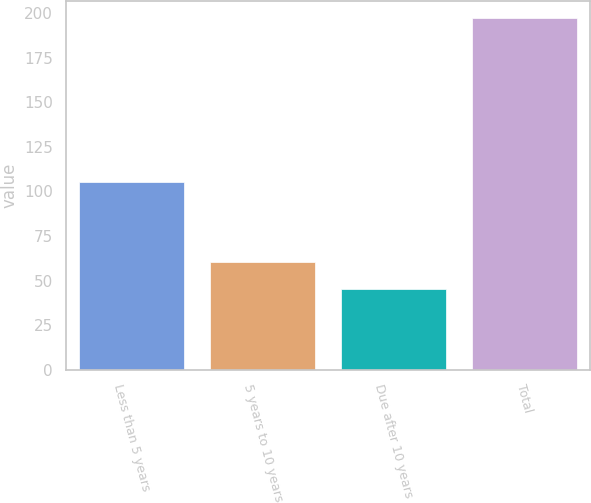Convert chart to OTSL. <chart><loc_0><loc_0><loc_500><loc_500><bar_chart><fcel>Less than 5 years<fcel>5 years to 10 years<fcel>Due after 10 years<fcel>Total<nl><fcel>105<fcel>60.2<fcel>45<fcel>197<nl></chart> 